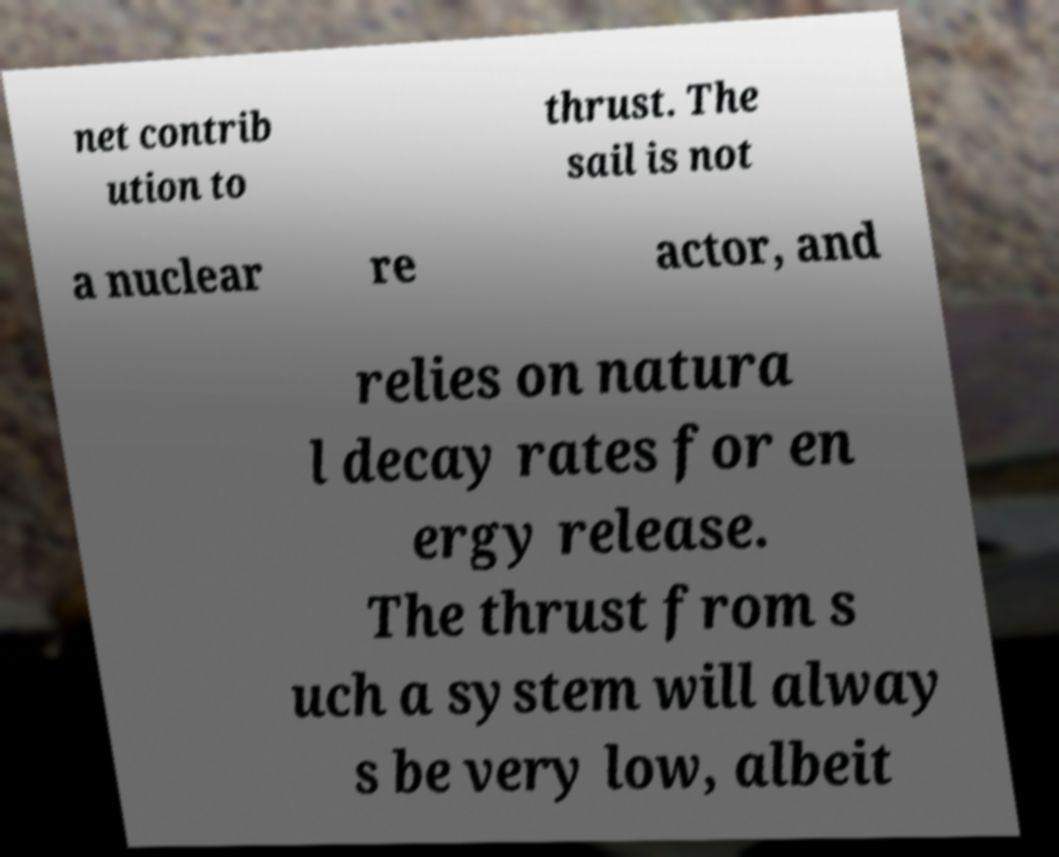There's text embedded in this image that I need extracted. Can you transcribe it verbatim? net contrib ution to thrust. The sail is not a nuclear re actor, and relies on natura l decay rates for en ergy release. The thrust from s uch a system will alway s be very low, albeit 